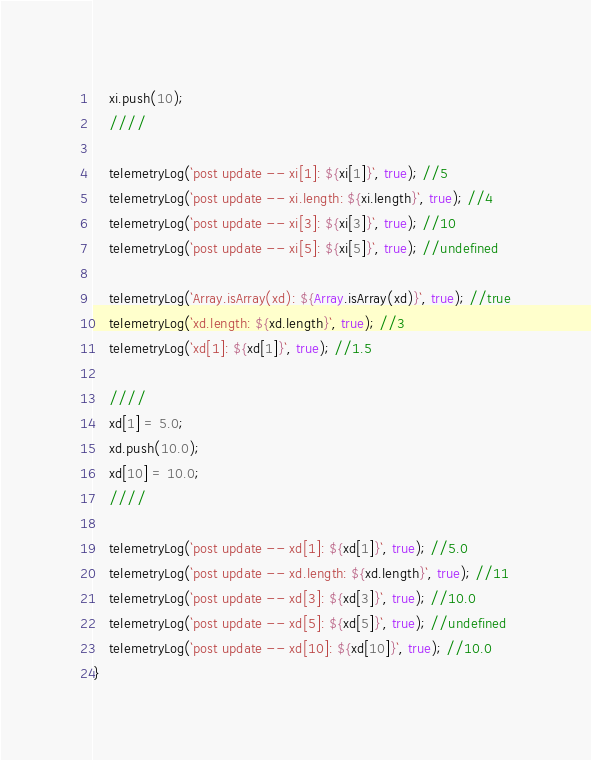<code> <loc_0><loc_0><loc_500><loc_500><_JavaScript_>    xi.push(10);
    ////

    telemetryLog(`post update -- xi[1]: ${xi[1]}`, true); //5
    telemetryLog(`post update -- xi.length: ${xi.length}`, true); //4
    telemetryLog(`post update -- xi[3]: ${xi[3]}`, true); //10
    telemetryLog(`post update -- xi[5]: ${xi[5]}`, true); //undefined

    telemetryLog(`Array.isArray(xd): ${Array.isArray(xd)}`, true); //true
    telemetryLog(`xd.length: ${xd.length}`, true); //3
    telemetryLog(`xd[1]: ${xd[1]}`, true); //1.5

    ////
    xd[1] = 5.0;
    xd.push(10.0);
    xd[10] = 10.0;
    ////

    telemetryLog(`post update -- xd[1]: ${xd[1]}`, true); //5.0
    telemetryLog(`post update -- xd.length: ${xd.length}`, true); //11
    telemetryLog(`post update -- xd[3]: ${xd[3]}`, true); //10.0
    telemetryLog(`post update -- xd[5]: ${xd[5]}`, true); //undefined
    telemetryLog(`post update -- xd[10]: ${xd[10]}`, true); //10.0
}</code> 